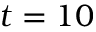<formula> <loc_0><loc_0><loc_500><loc_500>t = 1 0</formula> 